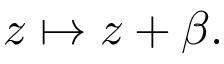<formula> <loc_0><loc_0><loc_500><loc_500>z \mapsto z + \beta .</formula> 